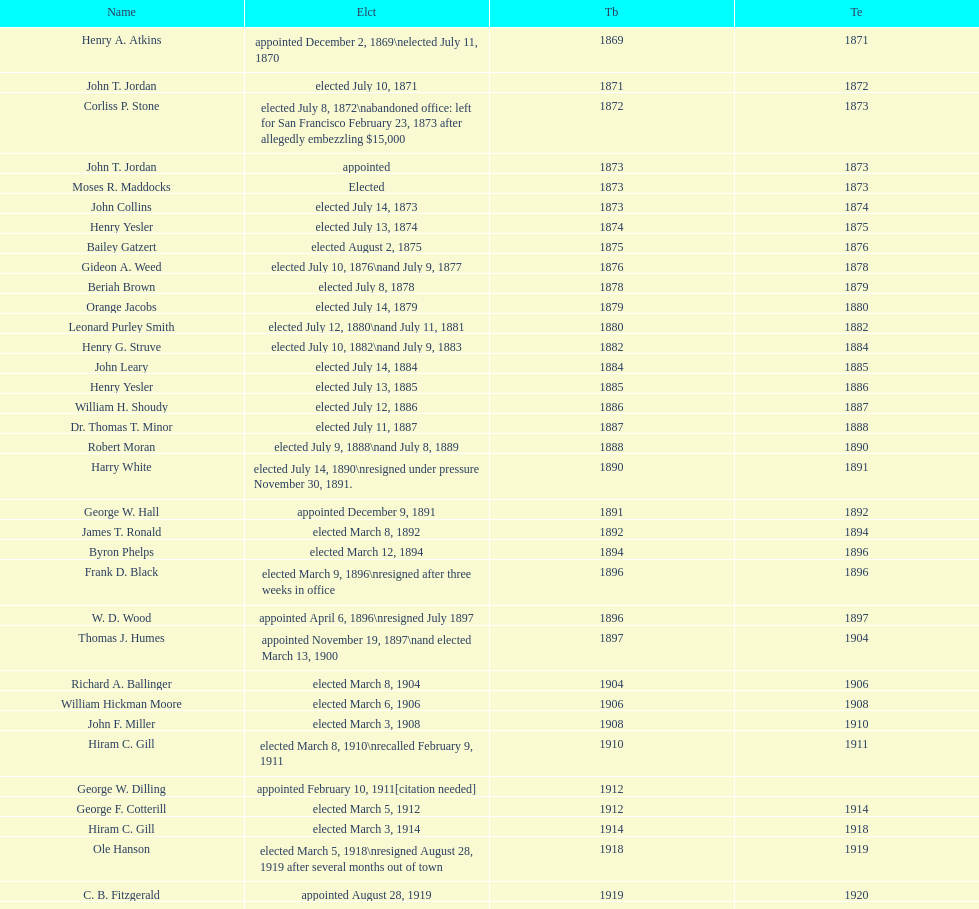Which mayor seattle, washington resigned after only three weeks in office in 1896? Frank D. Black. 